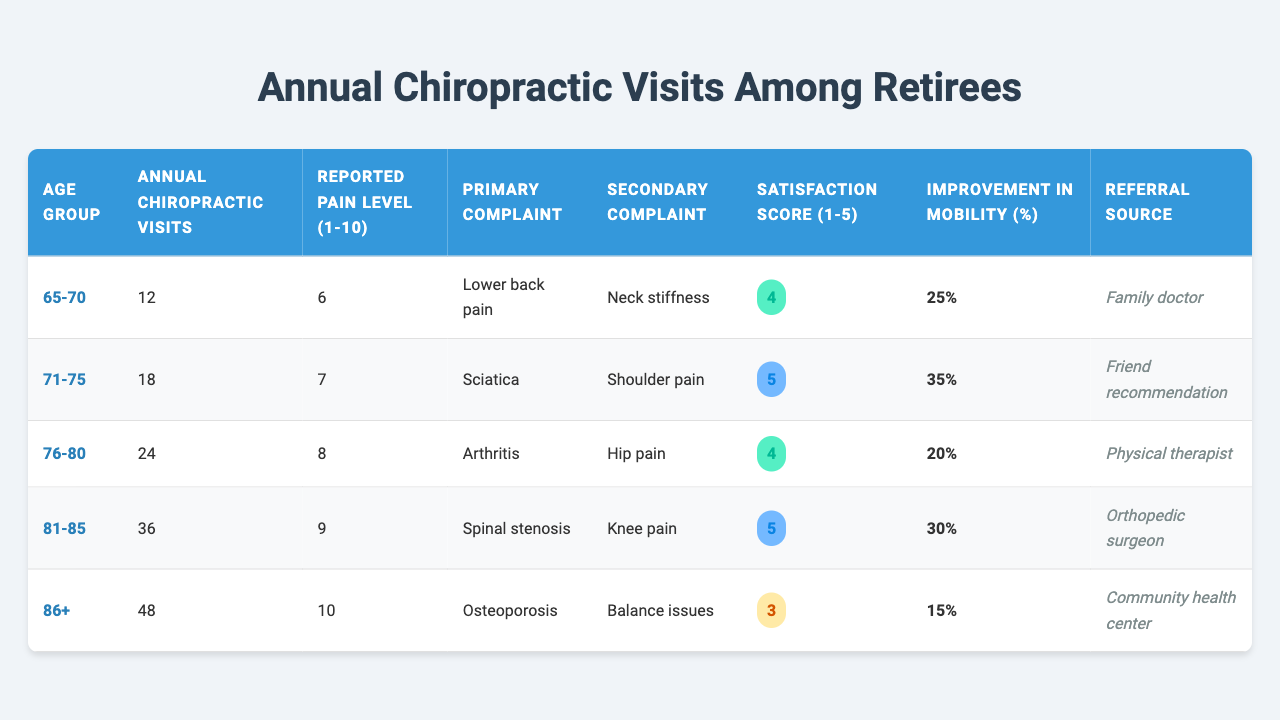What is the reported pain level for the age group 71-75? The table indicates that for the age group 71-75, the reported pain level is listed as 7.
Answer: 7 What is the maximum number of annual chiropractic visits recorded in the table? In the table, the age group 86+ has the maximum annual chiropractic visits listed at 48.
Answer: 48 Is the satisfaction score higher for the age group 76-80 compared to the age group 65-70? The satisfaction score for the age group 76-80 is 4, while for the age group 65-70 it is also 4, so they are equal.
Answer: No What is the average improvement in mobility percentage across all age groups? The improvement percentages are 25, 35, 20, 30, and 15. Summing these values gives 125. Dividing by the number of age groups, which is 5, results in an average of 25.
Answer: 25% For which age group is the primary complaint of "spinal stenosis" reported? The primary complaint of "spinal stenosis" is reported for the age group 81-85.
Answer: 81-85 How many chiropractic visits does the age group with the lowest pain level report? The age group 65-70 has the lowest pain level reported at 6, and they have 12 annual chiropractic visits.
Answer: 12 Which age group experiences the highest improvement in mobility percentage? The age group 71-75 reports the highest improvement in mobility percentage with a value of 35%.
Answer: 71-75 Is there a correlation indicating that as the number of annual chiropractic visits increases, the reported pain level also increases? Examining the table, as annual visits increase from 12 visits to 48 visits, the reported pain levels also increase from 6 to 10, indicating a positive correlation.
Answer: Yes What is the difference in reported pain levels between the age groups 76-80 and 81-85? The reported pain level for 76-80 is 8 and for 81-85 is 9. The difference is 9 - 8 = 1.
Answer: 1 What is the referral source for the age group with the highest satisfaction score? The age group 71-75, which has the highest satisfaction score of 5, reports their referral source as "Friend recommendation."
Answer: Friend recommendation 